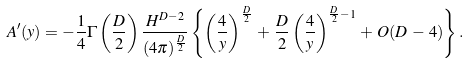<formula> <loc_0><loc_0><loc_500><loc_500>A ^ { \prime } ( y ) = - \frac { 1 } { 4 } \Gamma \left ( \frac { D } 2 \right ) \frac { H ^ { D - 2 } } { ( 4 \pi ) ^ { \frac { D } 2 } } \left \{ \left ( \frac { 4 } { y } \right ) ^ { \frac { D } 2 } \, + \, \frac { D } 2 \left ( \frac { 4 } { y } \right ) ^ { \frac { D } 2 - 1 } \, + \, O ( D \, - \, 4 ) \right \} .</formula> 